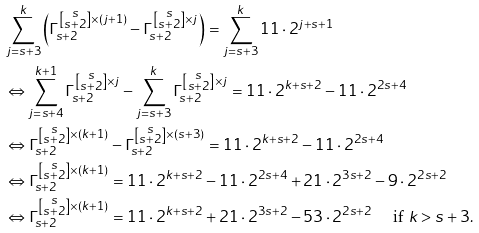Convert formula to latex. <formula><loc_0><loc_0><loc_500><loc_500>& \sum _ { j = s + 3 } ^ { k } \left ( \Gamma _ { s + 2 } ^ { \left [ \substack { s \\ s + 2 } \right ] \times ( j + 1 ) } - \Gamma _ { s + 2 } ^ { \left [ \substack { s \\ s + 2 } \right ] \times j } \right ) = \sum _ { j = s + 3 } ^ { k } 1 1 \cdot 2 ^ { j + s + 1 } \\ & \Leftrightarrow \sum _ { j = s + 4 } ^ { k + 1 } \Gamma _ { s + 2 } ^ { \left [ \substack { s \\ s + 2 } \right ] \times j } - \sum _ { j = s + 3 } ^ { k } \Gamma _ { s + 2 } ^ { \left [ \substack { s \\ s + 2 } \right ] \times j } = 1 1 \cdot 2 ^ { k + s + 2 } - 1 1 \cdot 2 ^ { 2 s + 4 } \\ & \Leftrightarrow \Gamma _ { s + 2 } ^ { \left [ \substack { s \\ s + 2 } \right ] \times ( k + 1 ) } - \Gamma _ { s + 2 } ^ { \left [ \substack { s \\ s + 2 } \right ] \times ( s + 3 ) } = 1 1 \cdot 2 ^ { k + s + 2 } - 1 1 \cdot 2 ^ { 2 s + 4 } \\ & \Leftrightarrow \Gamma _ { s + 2 } ^ { \left [ \substack { s \\ s + 2 } \right ] \times ( k + 1 ) } = 1 1 \cdot 2 ^ { k + s + 2 } - 1 1 \cdot 2 ^ { 2 s + 4 } + 2 1 \cdot 2 ^ { 3 s + 2 } - 9 \cdot 2 ^ { 2 s + 2 } \\ & \Leftrightarrow \Gamma _ { s + 2 } ^ { \left [ \substack { s \\ s + 2 } \right ] \times ( k + 1 ) } = 1 1 \cdot 2 ^ { k + s + 2 } + 2 1 \cdot 2 ^ { 3 s + 2 } - 5 3 \cdot 2 ^ { 2 s + 2 } \quad \text { if $ k > s+ 3 $} .</formula> 